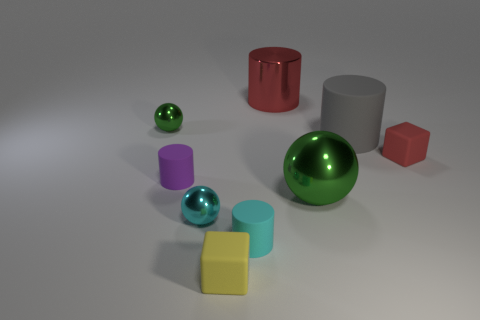Add 1 brown rubber blocks. How many objects exist? 10 Subtract all cyan cylinders. How many cylinders are left? 3 Subtract all purple cubes. How many green balls are left? 2 Subtract 1 cubes. How many cubes are left? 1 Subtract all cyan balls. How many balls are left? 2 Subtract all blocks. How many objects are left? 7 Add 9 tiny yellow objects. How many tiny yellow objects are left? 10 Add 5 green shiny objects. How many green shiny objects exist? 7 Subtract 1 gray cylinders. How many objects are left? 8 Subtract all green cylinders. Subtract all brown balls. How many cylinders are left? 4 